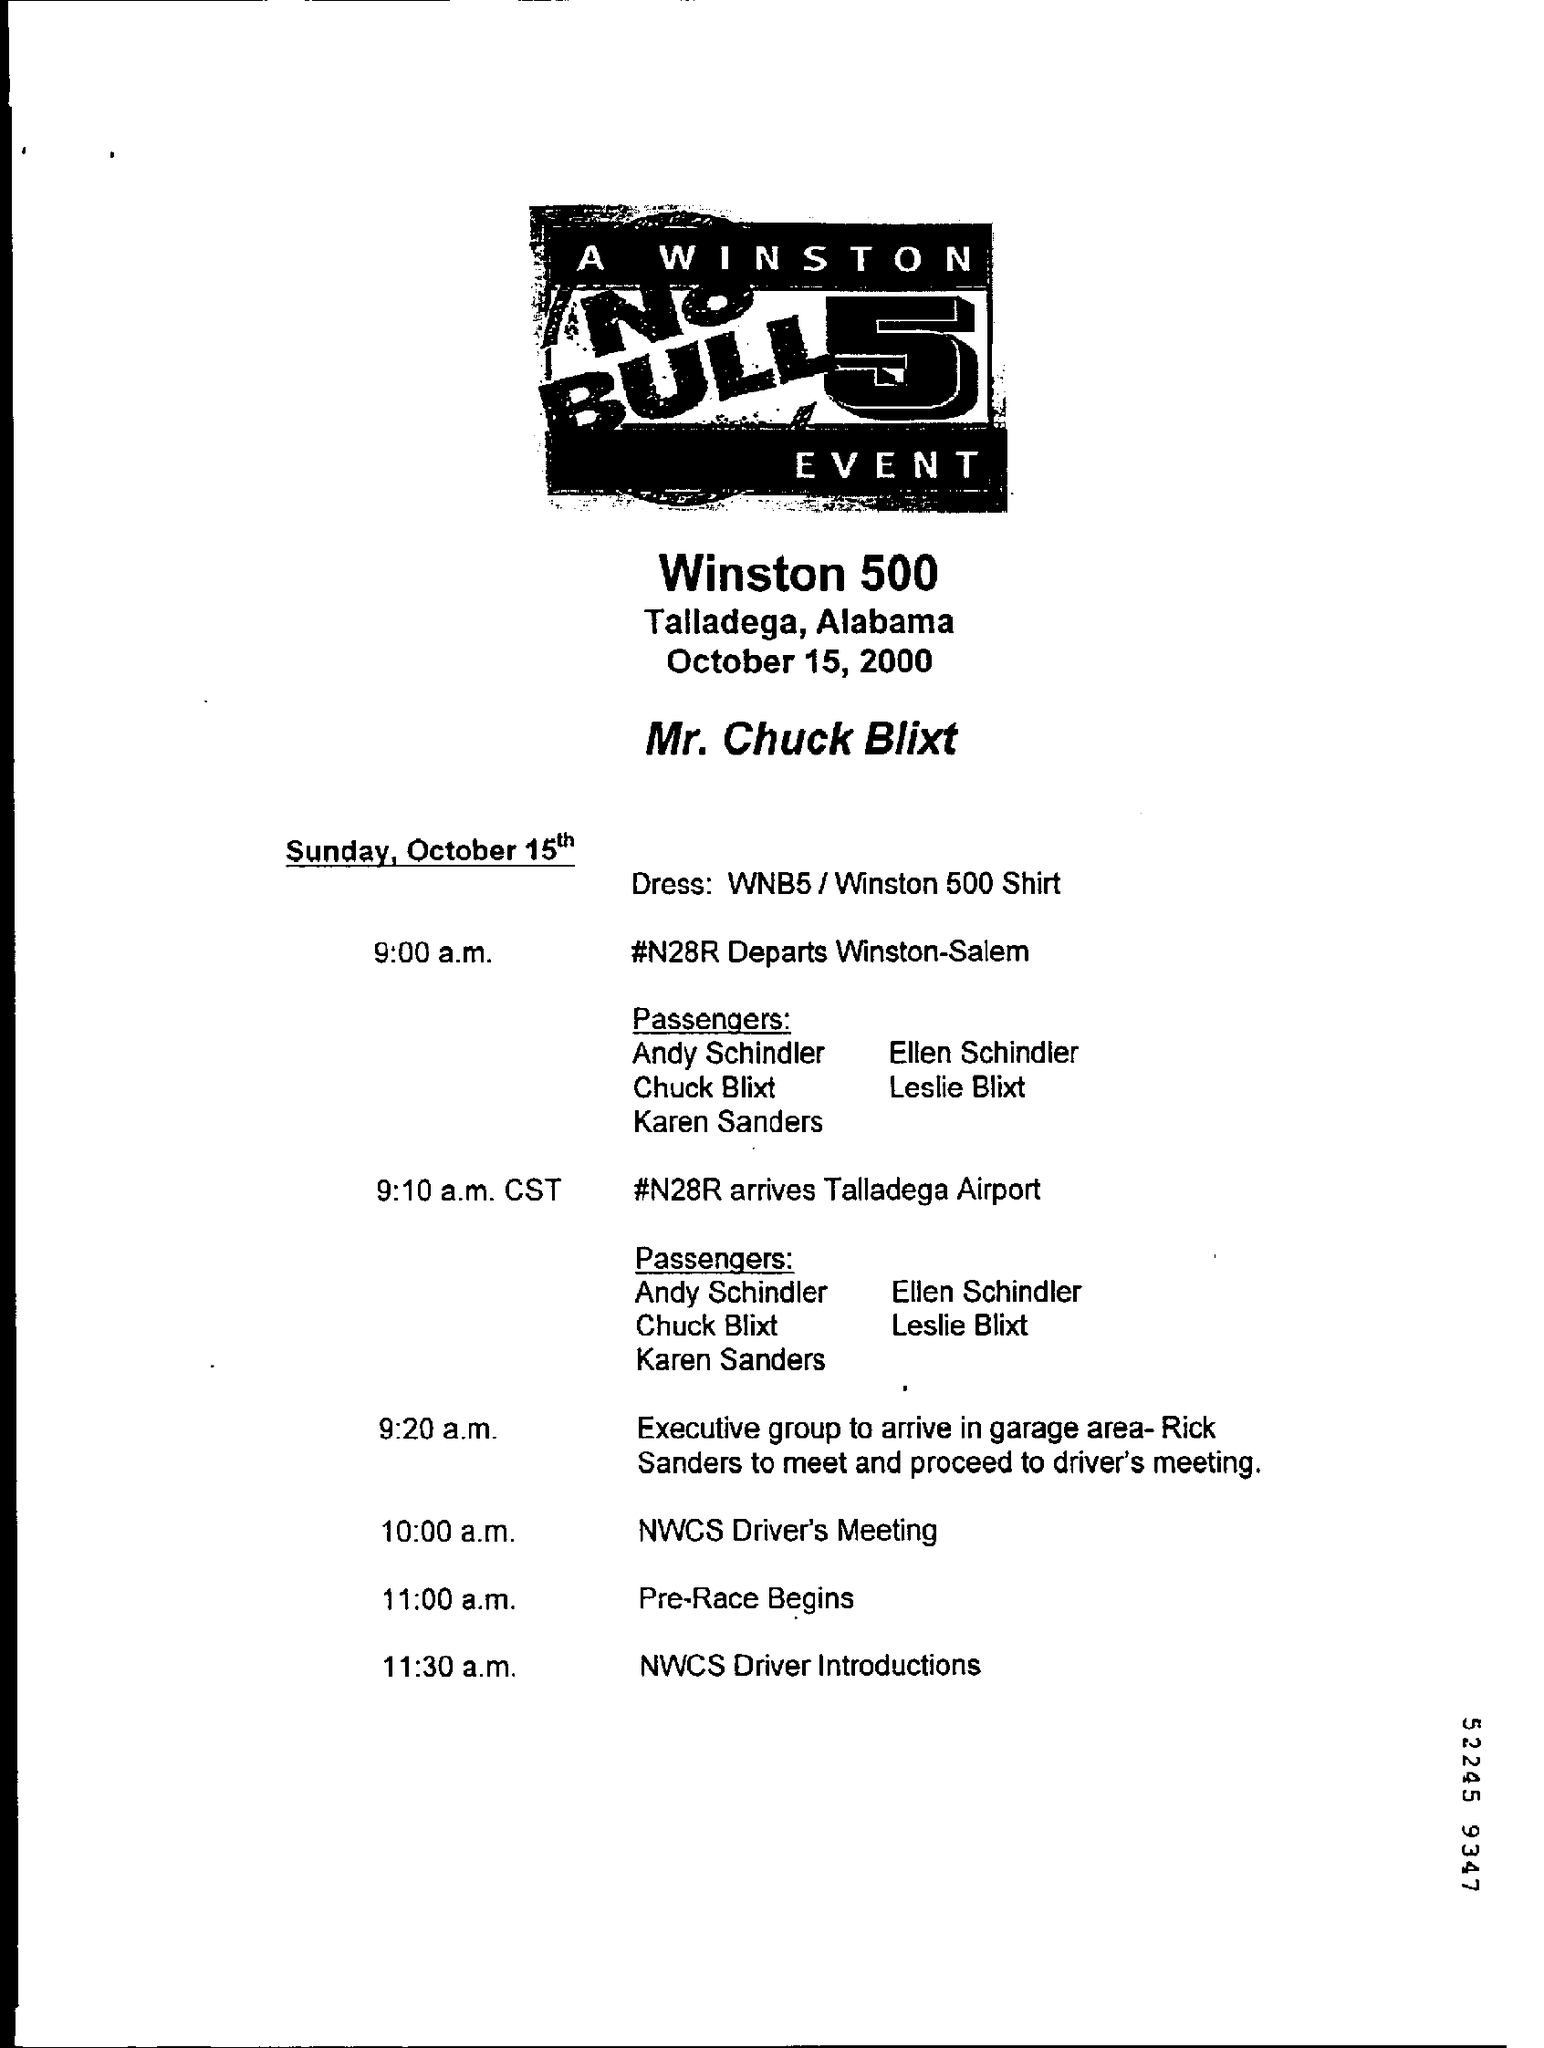Indicate a few pertinent items in this graphic. The NCWS Driver Introduction Session is scheduled to commence at 11:30 a.m... At 9:00 a.m. on day N28R, the departure of Winston-Salem is scheduled. The place is Talladega, Alabama. The date and time of the NCWS Driver's Meeting is 10:00 a.m. The flight #N28R is expected to arrive at Talladega Airport at 9:10 a.m. Central Standard Time. 